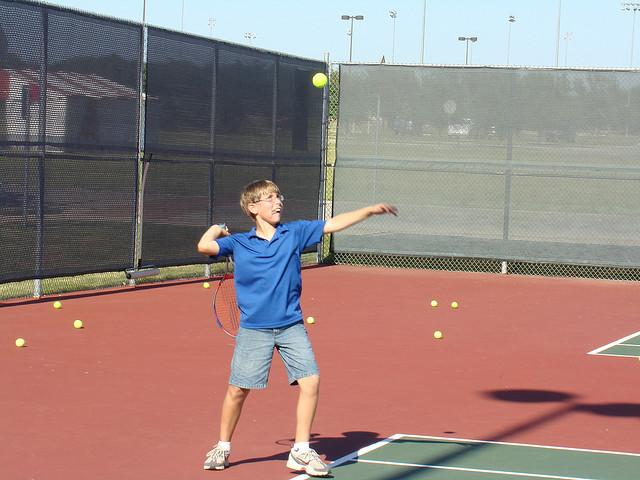What type of shot is the boy about to hit? Please explain your reasoning. serve. He has thrown the ball above himself and has the racket behind him to do a large swing 